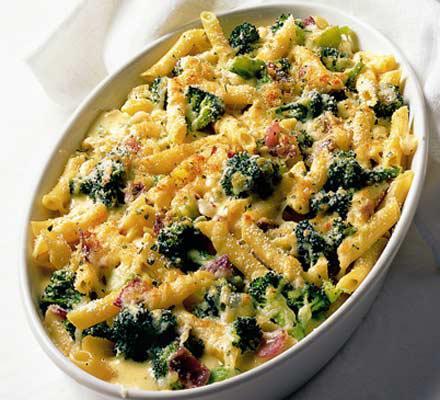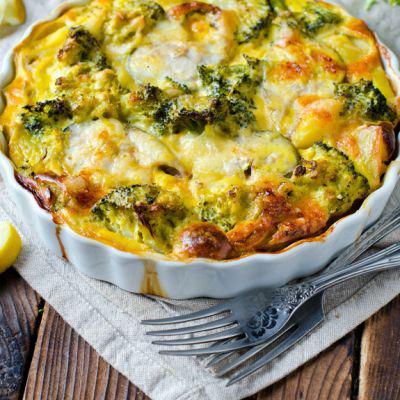The first image is the image on the left, the second image is the image on the right. Analyze the images presented: Is the assertion "A meal is served on a red container." valid? Answer yes or no. No. 